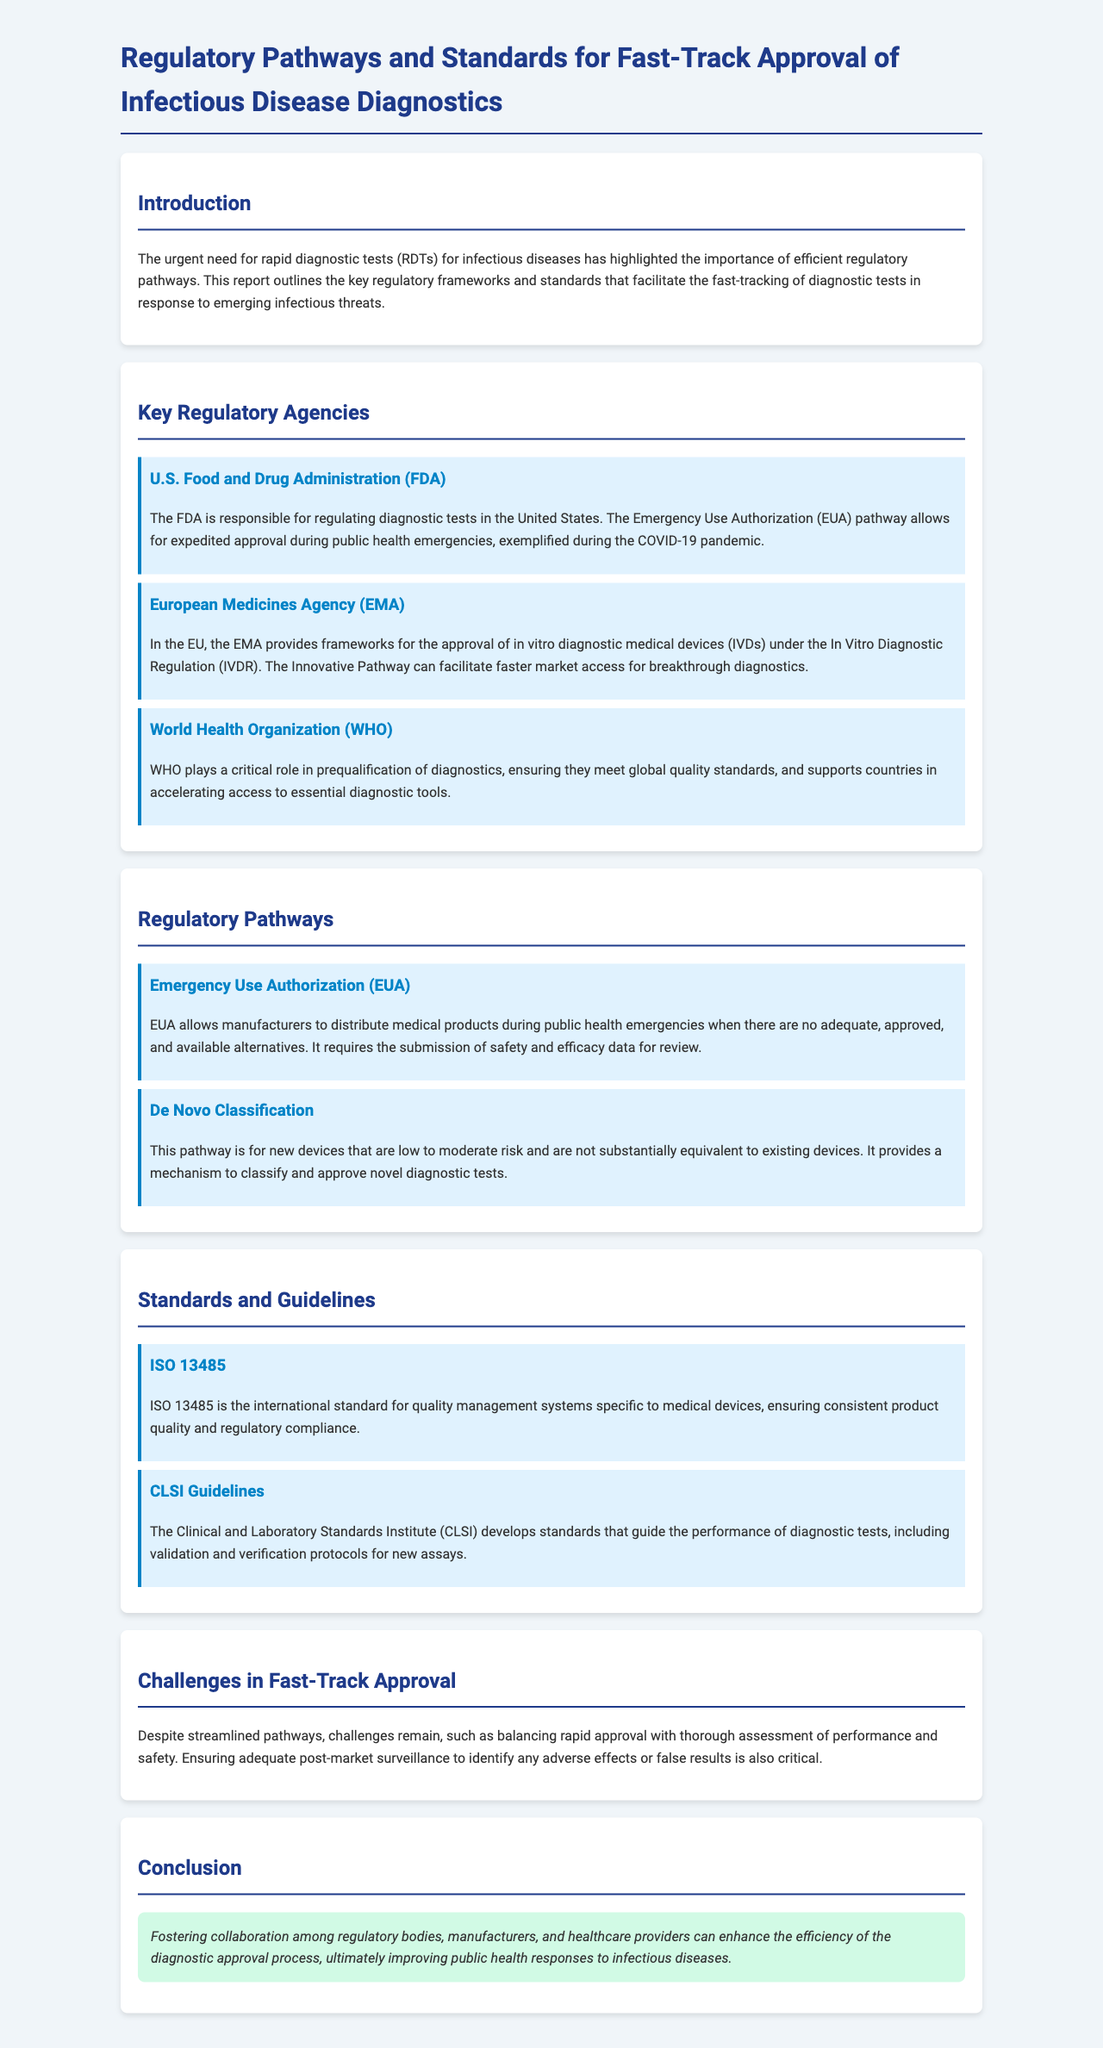What is the main focus of the report? The report outlines the key regulatory frameworks and standards that facilitate the fast-tracking of diagnostic tests in response to emerging infectious threats.
Answer: regulatory pathways and standards for fast-track approval of infectious disease diagnostics Which agency is responsible for regulating diagnostic tests in the United States? The document states that the FDA is responsible for regulating diagnostic tests in the United States.
Answer: FDA What pathway allows for expedited approval during public health emergencies? The report mentions the Emergency Use Authorization (EUA) pathway allows for expedited approval during public health emergencies.
Answer: Emergency Use Authorization (EUA) What is a key challenge mentioned regarding fast-track approval? The document highlights the challenge of balancing rapid approval with thorough assessment of performance and safety.
Answer: balancing rapid approval with thorough assessment What standard is specific to quality management systems for medical devices? The report specifies that ISO 13485 is the international standard for quality management systems specific to medical devices.
Answer: ISO 13485 